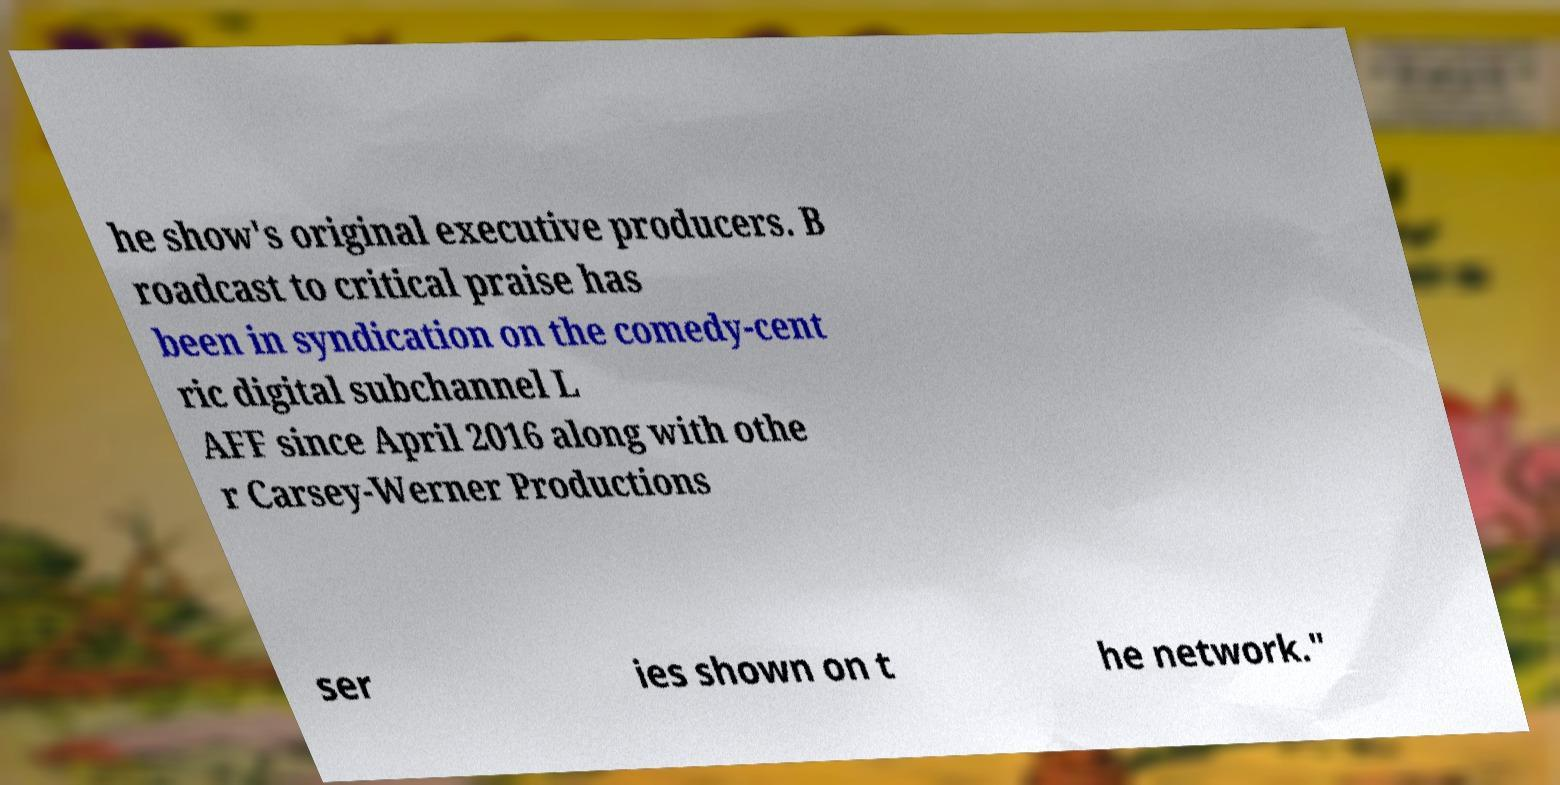I need the written content from this picture converted into text. Can you do that? he show's original executive producers. B roadcast to critical praise has been in syndication on the comedy-cent ric digital subchannel L AFF since April 2016 along with othe r Carsey-Werner Productions ser ies shown on t he network." 